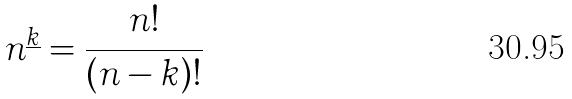<formula> <loc_0><loc_0><loc_500><loc_500>n ^ { \underline { k } } = \frac { n ! } { ( n - k ) ! }</formula> 